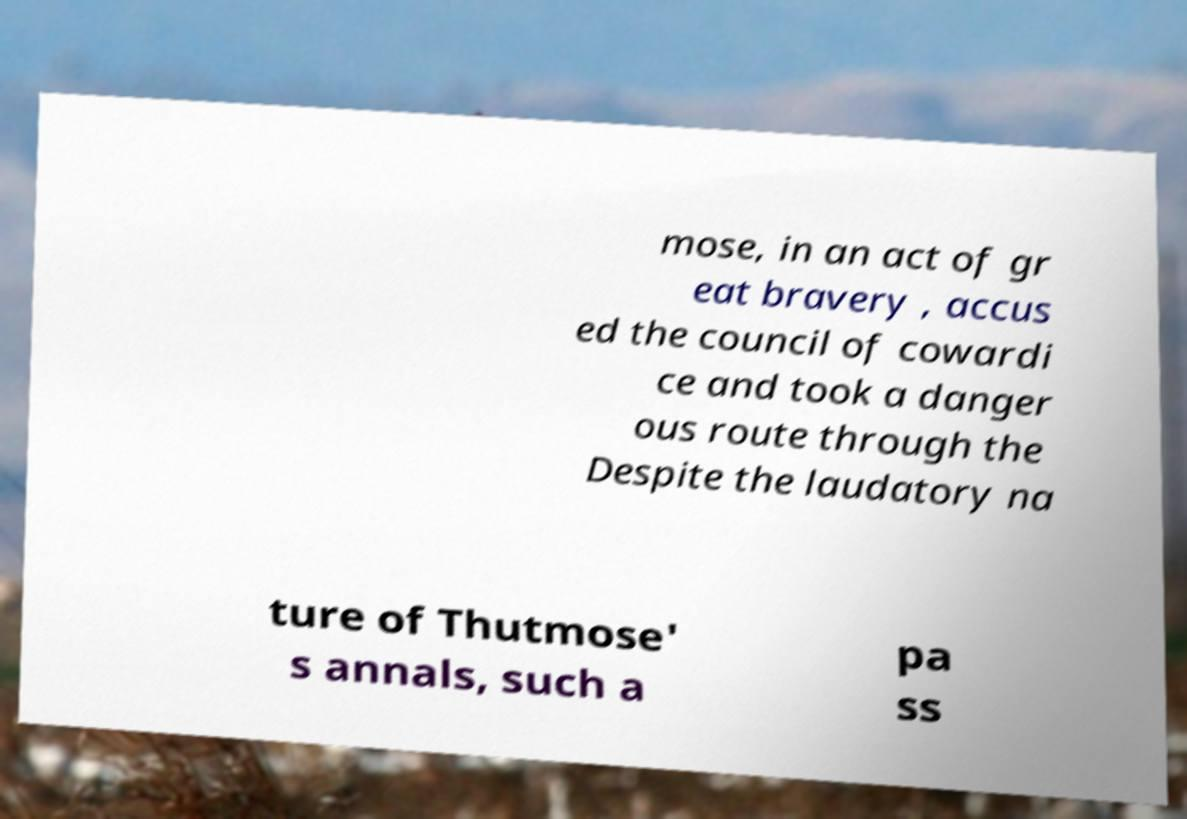Could you assist in decoding the text presented in this image and type it out clearly? mose, in an act of gr eat bravery , accus ed the council of cowardi ce and took a danger ous route through the Despite the laudatory na ture of Thutmose' s annals, such a pa ss 